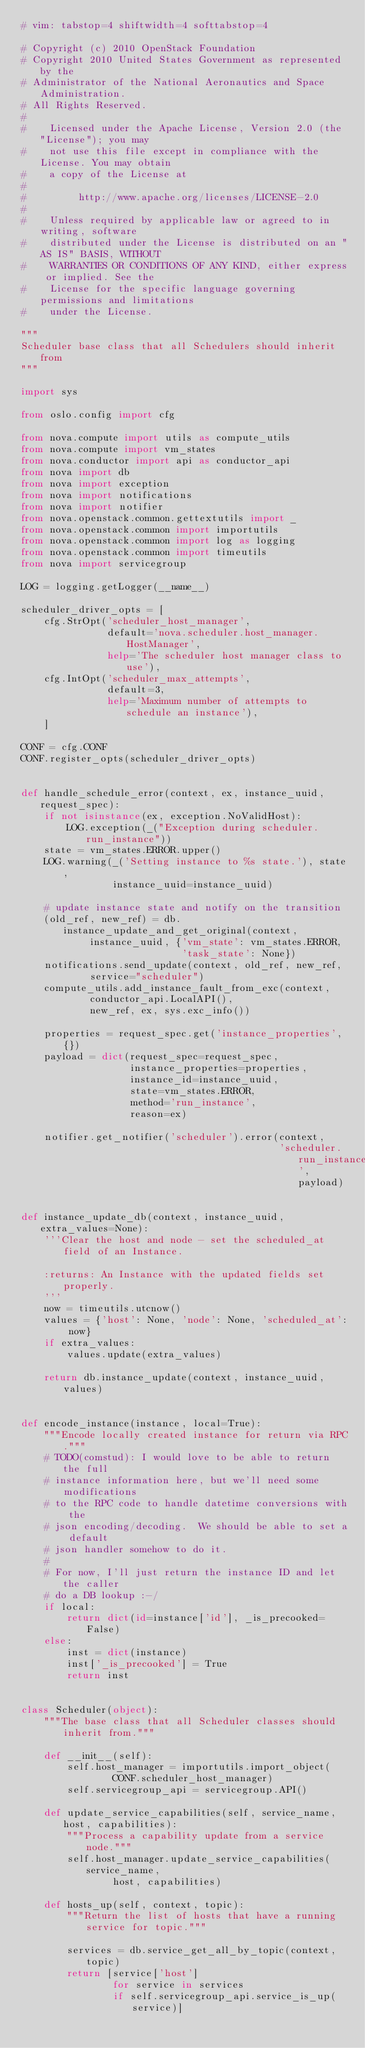Convert code to text. <code><loc_0><loc_0><loc_500><loc_500><_Python_># vim: tabstop=4 shiftwidth=4 softtabstop=4

# Copyright (c) 2010 OpenStack Foundation
# Copyright 2010 United States Government as represented by the
# Administrator of the National Aeronautics and Space Administration.
# All Rights Reserved.
#
#    Licensed under the Apache License, Version 2.0 (the "License"); you may
#    not use this file except in compliance with the License. You may obtain
#    a copy of the License at
#
#         http://www.apache.org/licenses/LICENSE-2.0
#
#    Unless required by applicable law or agreed to in writing, software
#    distributed under the License is distributed on an "AS IS" BASIS, WITHOUT
#    WARRANTIES OR CONDITIONS OF ANY KIND, either express or implied. See the
#    License for the specific language governing permissions and limitations
#    under the License.

"""
Scheduler base class that all Schedulers should inherit from
"""

import sys

from oslo.config import cfg

from nova.compute import utils as compute_utils
from nova.compute import vm_states
from nova.conductor import api as conductor_api
from nova import db
from nova import exception
from nova import notifications
from nova import notifier
from nova.openstack.common.gettextutils import _
from nova.openstack.common import importutils
from nova.openstack.common import log as logging
from nova.openstack.common import timeutils
from nova import servicegroup

LOG = logging.getLogger(__name__)

scheduler_driver_opts = [
    cfg.StrOpt('scheduler_host_manager',
               default='nova.scheduler.host_manager.HostManager',
               help='The scheduler host manager class to use'),
    cfg.IntOpt('scheduler_max_attempts',
               default=3,
               help='Maximum number of attempts to schedule an instance'),
    ]

CONF = cfg.CONF
CONF.register_opts(scheduler_driver_opts)


def handle_schedule_error(context, ex, instance_uuid, request_spec):
    if not isinstance(ex, exception.NoValidHost):
        LOG.exception(_("Exception during scheduler.run_instance"))
    state = vm_states.ERROR.upper()
    LOG.warning(_('Setting instance to %s state.'), state,
                instance_uuid=instance_uuid)

    # update instance state and notify on the transition
    (old_ref, new_ref) = db.instance_update_and_get_original(context,
            instance_uuid, {'vm_state': vm_states.ERROR,
                            'task_state': None})
    notifications.send_update(context, old_ref, new_ref,
            service="scheduler")
    compute_utils.add_instance_fault_from_exc(context,
            conductor_api.LocalAPI(),
            new_ref, ex, sys.exc_info())

    properties = request_spec.get('instance_properties', {})
    payload = dict(request_spec=request_spec,
                   instance_properties=properties,
                   instance_id=instance_uuid,
                   state=vm_states.ERROR,
                   method='run_instance',
                   reason=ex)

    notifier.get_notifier('scheduler').error(context,
                                             'scheduler.run_instance', payload)


def instance_update_db(context, instance_uuid, extra_values=None):
    '''Clear the host and node - set the scheduled_at field of an Instance.

    :returns: An Instance with the updated fields set properly.
    '''
    now = timeutils.utcnow()
    values = {'host': None, 'node': None, 'scheduled_at': now}
    if extra_values:
        values.update(extra_values)

    return db.instance_update(context, instance_uuid, values)


def encode_instance(instance, local=True):
    """Encode locally created instance for return via RPC."""
    # TODO(comstud): I would love to be able to return the full
    # instance information here, but we'll need some modifications
    # to the RPC code to handle datetime conversions with the
    # json encoding/decoding.  We should be able to set a default
    # json handler somehow to do it.
    #
    # For now, I'll just return the instance ID and let the caller
    # do a DB lookup :-/
    if local:
        return dict(id=instance['id'], _is_precooked=False)
    else:
        inst = dict(instance)
        inst['_is_precooked'] = True
        return inst


class Scheduler(object):
    """The base class that all Scheduler classes should inherit from."""

    def __init__(self):
        self.host_manager = importutils.import_object(
                CONF.scheduler_host_manager)
        self.servicegroup_api = servicegroup.API()

    def update_service_capabilities(self, service_name, host, capabilities):
        """Process a capability update from a service node."""
        self.host_manager.update_service_capabilities(service_name,
                host, capabilities)

    def hosts_up(self, context, topic):
        """Return the list of hosts that have a running service for topic."""

        services = db.service_get_all_by_topic(context, topic)
        return [service['host']
                for service in services
                if self.servicegroup_api.service_is_up(service)]
</code> 